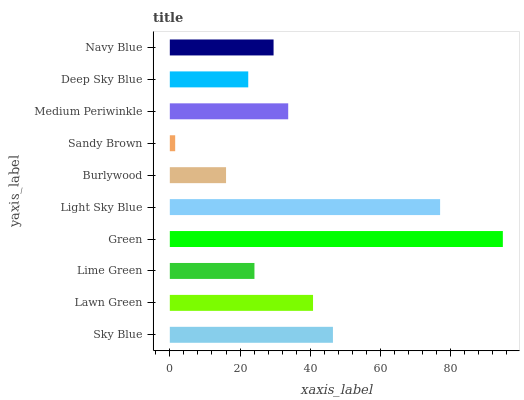Is Sandy Brown the minimum?
Answer yes or no. Yes. Is Green the maximum?
Answer yes or no. Yes. Is Lawn Green the minimum?
Answer yes or no. No. Is Lawn Green the maximum?
Answer yes or no. No. Is Sky Blue greater than Lawn Green?
Answer yes or no. Yes. Is Lawn Green less than Sky Blue?
Answer yes or no. Yes. Is Lawn Green greater than Sky Blue?
Answer yes or no. No. Is Sky Blue less than Lawn Green?
Answer yes or no. No. Is Medium Periwinkle the high median?
Answer yes or no. Yes. Is Navy Blue the low median?
Answer yes or no. Yes. Is Green the high median?
Answer yes or no. No. Is Medium Periwinkle the low median?
Answer yes or no. No. 